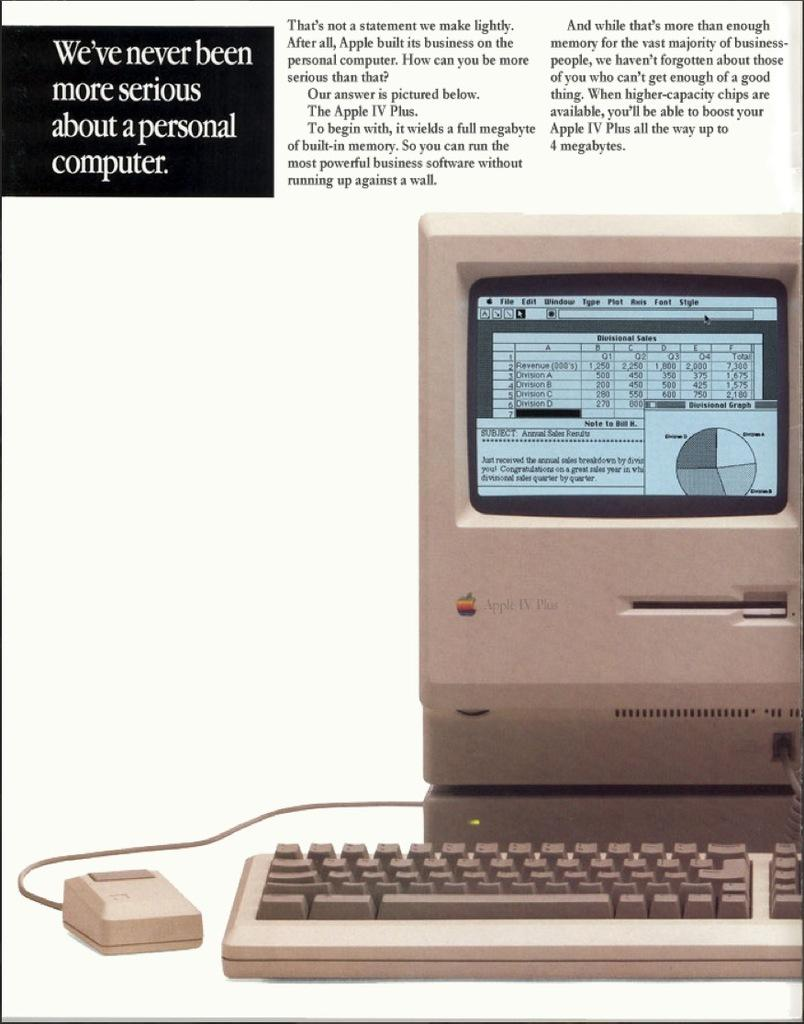<image>
Relay a brief, clear account of the picture shown. advertisement for Apple IV Plus computer running a spreadsheet program 